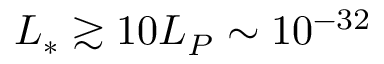Convert formula to latex. <formula><loc_0><loc_0><loc_500><loc_500>L _ { * } \gtrsim 1 0 L _ { P } \sim 1 0 ^ { - 3 2 }</formula> 